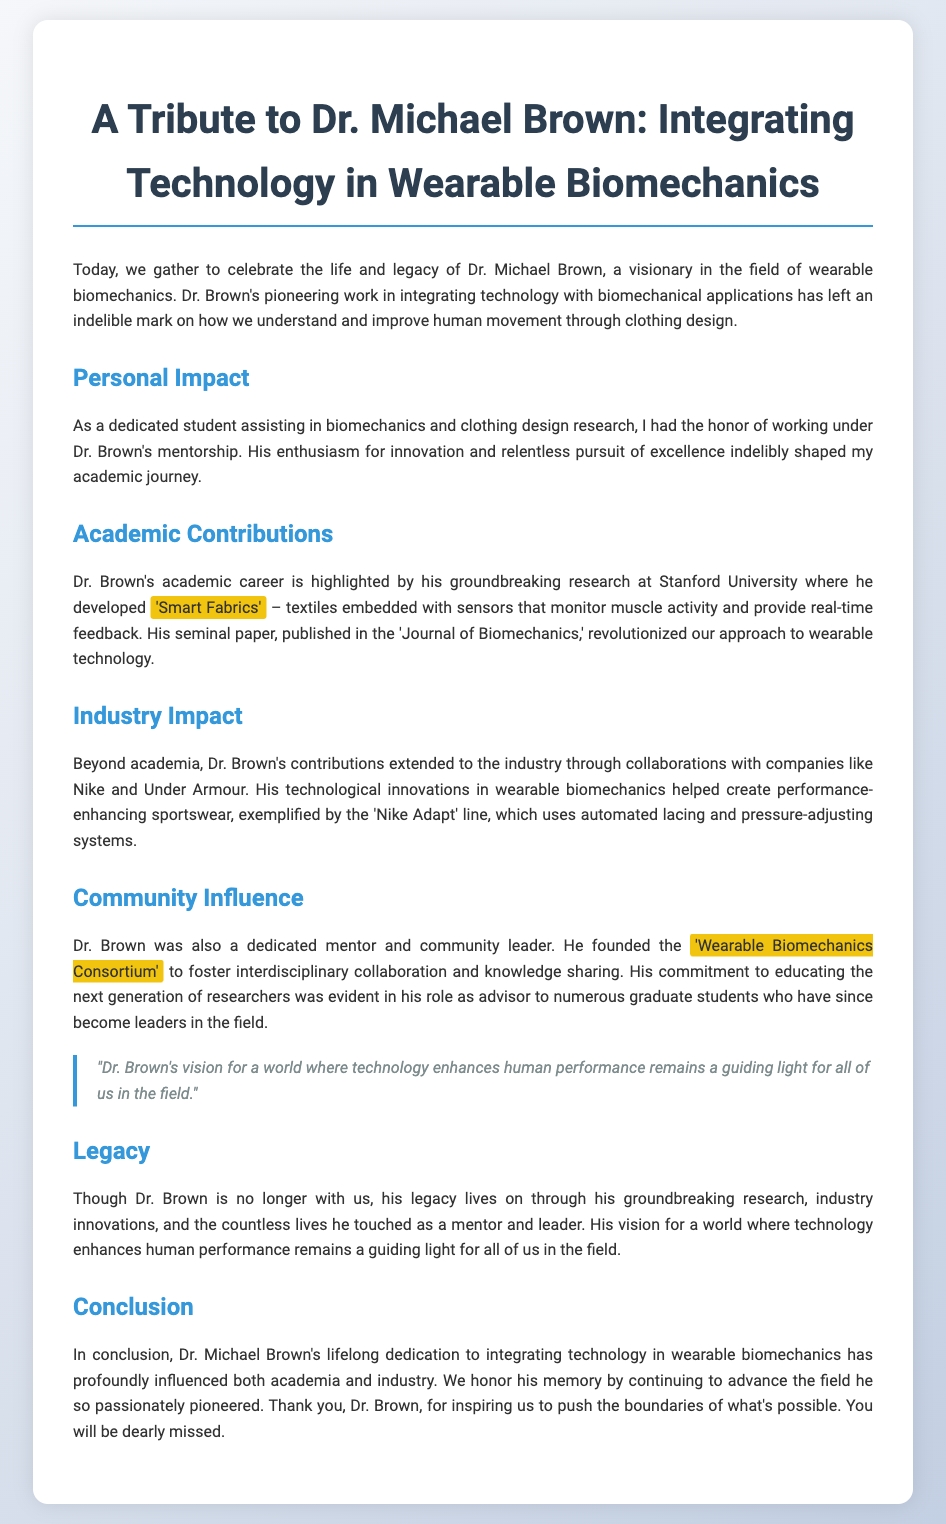What is Dr. Michael Brown known for? Dr. Michael Brown is known for his pioneering work in integrating technology with biomechanical applications.
Answer: Integrating technology with biomechanical applications What university did Dr. Brown work at? The document mentions that Dr. Brown conducted groundbreaking research at Stanford University.
Answer: Stanford University What is the name of the technology Dr. Brown developed? Dr. Brown developed 'Smart Fabrics', which are textiles embedded with sensors.
Answer: 'Smart Fabrics' Which companies did Dr. Brown collaborate with? The document lists Nike and Under Armour as companies Dr. Brown collaborated with.
Answer: Nike and Under Armour What did the 'Nike Adapt' line feature? The 'Nike Adapt' line features automated lacing and pressure-adjusting systems.
Answer: Automated lacing and pressure-adjusting systems What consortium did Dr. Brown found? Dr. Brown founded the 'Wearable Biomechanics Consortium'.
Answer: 'Wearable Biomechanics Consortium' How did Dr. Brown influence his students? Dr. Brown’s commitment to educating the next generation was evident in his role as an advisor to numerous graduate students.
Answer: As an advisor to numerous graduate students What is a guiding principle mentioned about Dr. Brown's vision? The document states that Dr. Brown’s vision for a world where technology enhances human performance remains a guiding light.
Answer: A guiding light for all of us in the field What is the main theme of the conclusion? The conclusion emphasizes Dr. Brown's lifelong dedication to integrating technology in wearable biomechanics.
Answer: Lifelong dedication to integrating technology in wearable biomechanics 